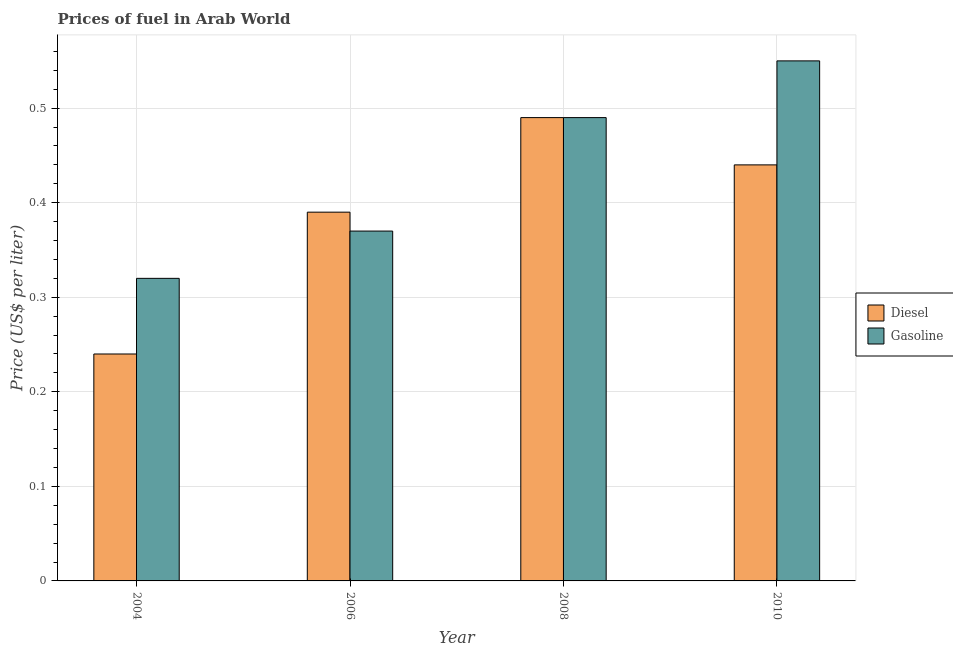Are the number of bars on each tick of the X-axis equal?
Provide a succinct answer. Yes. How many bars are there on the 3rd tick from the right?
Make the answer very short. 2. What is the label of the 1st group of bars from the left?
Your answer should be compact. 2004. What is the gasoline price in 2004?
Your answer should be very brief. 0.32. Across all years, what is the maximum diesel price?
Make the answer very short. 0.49. Across all years, what is the minimum diesel price?
Keep it short and to the point. 0.24. In which year was the diesel price minimum?
Your response must be concise. 2004. What is the total diesel price in the graph?
Make the answer very short. 1.56. What is the difference between the gasoline price in 2008 and that in 2010?
Your answer should be very brief. -0.06. What is the difference between the diesel price in 2008 and the gasoline price in 2010?
Provide a short and direct response. 0.05. What is the average gasoline price per year?
Your answer should be compact. 0.43. What is the ratio of the gasoline price in 2004 to that in 2008?
Keep it short and to the point. 0.65. Is the difference between the diesel price in 2004 and 2006 greater than the difference between the gasoline price in 2004 and 2006?
Keep it short and to the point. No. What is the difference between the highest and the second highest diesel price?
Offer a very short reply. 0.05. What is the difference between the highest and the lowest gasoline price?
Ensure brevity in your answer.  0.23. Is the sum of the gasoline price in 2008 and 2010 greater than the maximum diesel price across all years?
Provide a succinct answer. Yes. What does the 2nd bar from the left in 2008 represents?
Keep it short and to the point. Gasoline. What does the 2nd bar from the right in 2004 represents?
Make the answer very short. Diesel. How many bars are there?
Make the answer very short. 8. Does the graph contain grids?
Give a very brief answer. Yes. How are the legend labels stacked?
Your answer should be very brief. Vertical. What is the title of the graph?
Provide a succinct answer. Prices of fuel in Arab World. Does "Female" appear as one of the legend labels in the graph?
Give a very brief answer. No. What is the label or title of the Y-axis?
Make the answer very short. Price (US$ per liter). What is the Price (US$ per liter) in Diesel in 2004?
Offer a terse response. 0.24. What is the Price (US$ per liter) in Gasoline in 2004?
Your answer should be very brief. 0.32. What is the Price (US$ per liter) of Diesel in 2006?
Offer a terse response. 0.39. What is the Price (US$ per liter) in Gasoline in 2006?
Provide a succinct answer. 0.37. What is the Price (US$ per liter) in Diesel in 2008?
Give a very brief answer. 0.49. What is the Price (US$ per liter) of Gasoline in 2008?
Your response must be concise. 0.49. What is the Price (US$ per liter) in Diesel in 2010?
Make the answer very short. 0.44. What is the Price (US$ per liter) in Gasoline in 2010?
Provide a succinct answer. 0.55. Across all years, what is the maximum Price (US$ per liter) in Diesel?
Your response must be concise. 0.49. Across all years, what is the maximum Price (US$ per liter) in Gasoline?
Your response must be concise. 0.55. Across all years, what is the minimum Price (US$ per liter) of Diesel?
Make the answer very short. 0.24. Across all years, what is the minimum Price (US$ per liter) in Gasoline?
Ensure brevity in your answer.  0.32. What is the total Price (US$ per liter) in Diesel in the graph?
Provide a succinct answer. 1.56. What is the total Price (US$ per liter) of Gasoline in the graph?
Your answer should be compact. 1.73. What is the difference between the Price (US$ per liter) of Gasoline in 2004 and that in 2008?
Offer a very short reply. -0.17. What is the difference between the Price (US$ per liter) in Diesel in 2004 and that in 2010?
Keep it short and to the point. -0.2. What is the difference between the Price (US$ per liter) in Gasoline in 2004 and that in 2010?
Give a very brief answer. -0.23. What is the difference between the Price (US$ per liter) in Gasoline in 2006 and that in 2008?
Provide a short and direct response. -0.12. What is the difference between the Price (US$ per liter) in Gasoline in 2006 and that in 2010?
Your response must be concise. -0.18. What is the difference between the Price (US$ per liter) in Gasoline in 2008 and that in 2010?
Your answer should be compact. -0.06. What is the difference between the Price (US$ per liter) of Diesel in 2004 and the Price (US$ per liter) of Gasoline in 2006?
Make the answer very short. -0.13. What is the difference between the Price (US$ per liter) of Diesel in 2004 and the Price (US$ per liter) of Gasoline in 2010?
Offer a very short reply. -0.31. What is the difference between the Price (US$ per liter) of Diesel in 2006 and the Price (US$ per liter) of Gasoline in 2010?
Your answer should be compact. -0.16. What is the difference between the Price (US$ per liter) in Diesel in 2008 and the Price (US$ per liter) in Gasoline in 2010?
Provide a succinct answer. -0.06. What is the average Price (US$ per liter) of Diesel per year?
Offer a terse response. 0.39. What is the average Price (US$ per liter) of Gasoline per year?
Your answer should be very brief. 0.43. In the year 2004, what is the difference between the Price (US$ per liter) of Diesel and Price (US$ per liter) of Gasoline?
Your answer should be compact. -0.08. In the year 2008, what is the difference between the Price (US$ per liter) in Diesel and Price (US$ per liter) in Gasoline?
Ensure brevity in your answer.  0. In the year 2010, what is the difference between the Price (US$ per liter) in Diesel and Price (US$ per liter) in Gasoline?
Ensure brevity in your answer.  -0.11. What is the ratio of the Price (US$ per liter) in Diesel in 2004 to that in 2006?
Give a very brief answer. 0.62. What is the ratio of the Price (US$ per liter) in Gasoline in 2004 to that in 2006?
Give a very brief answer. 0.86. What is the ratio of the Price (US$ per liter) of Diesel in 2004 to that in 2008?
Your response must be concise. 0.49. What is the ratio of the Price (US$ per liter) in Gasoline in 2004 to that in 2008?
Your answer should be compact. 0.65. What is the ratio of the Price (US$ per liter) in Diesel in 2004 to that in 2010?
Make the answer very short. 0.55. What is the ratio of the Price (US$ per liter) of Gasoline in 2004 to that in 2010?
Your answer should be very brief. 0.58. What is the ratio of the Price (US$ per liter) in Diesel in 2006 to that in 2008?
Ensure brevity in your answer.  0.8. What is the ratio of the Price (US$ per liter) in Gasoline in 2006 to that in 2008?
Provide a short and direct response. 0.76. What is the ratio of the Price (US$ per liter) in Diesel in 2006 to that in 2010?
Provide a succinct answer. 0.89. What is the ratio of the Price (US$ per liter) in Gasoline in 2006 to that in 2010?
Offer a terse response. 0.67. What is the ratio of the Price (US$ per liter) of Diesel in 2008 to that in 2010?
Offer a very short reply. 1.11. What is the ratio of the Price (US$ per liter) of Gasoline in 2008 to that in 2010?
Keep it short and to the point. 0.89. What is the difference between the highest and the second highest Price (US$ per liter) of Diesel?
Your answer should be very brief. 0.05. What is the difference between the highest and the second highest Price (US$ per liter) of Gasoline?
Your response must be concise. 0.06. What is the difference between the highest and the lowest Price (US$ per liter) of Gasoline?
Keep it short and to the point. 0.23. 